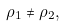<formula> <loc_0><loc_0><loc_500><loc_500>\rho _ { 1 } \neq \rho _ { 2 } ,</formula> 